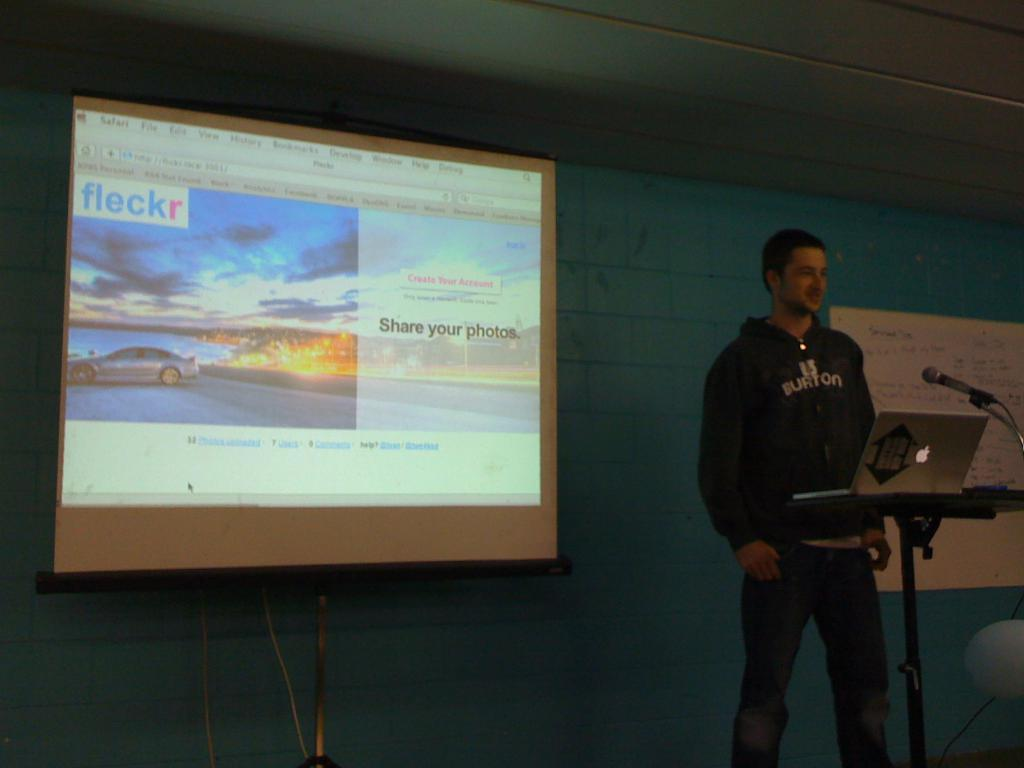<image>
Summarize the visual content of the image. the word share in on the image on the screen 